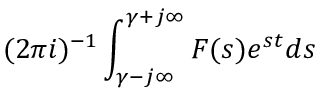Convert formula to latex. <formula><loc_0><loc_0><loc_500><loc_500>( 2 \pi i ) ^ { - 1 } \int _ { \gamma - j \infty } ^ { \gamma + j \infty } F ( s ) e ^ { s t } d s</formula> 